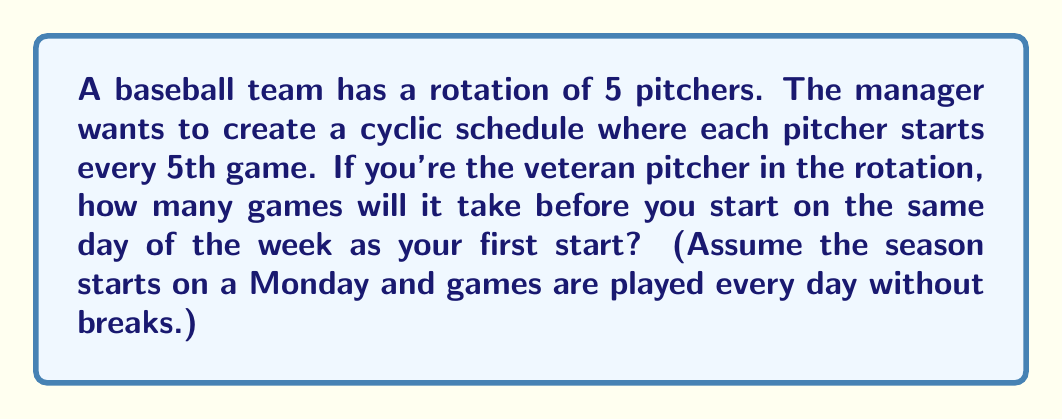Can you answer this question? Let's approach this step-by-step:

1) First, we need to understand what creates the cyclic subgroup in this scenario. The rotation of 5 pitchers combined with the 7 days of the week creates a cyclic pattern.

2) We can represent this as a permutation. Let's call the days of the week $1, 2, 3, 4, 5, 6, 7$ (Monday to Sunday) and our pitcher's position in the rotation as $x$. The permutation can be written as:

   $$(x, x+5, x+10, x+15, ...)$$

   Where we take the result modulo 7 to stay within the days of the week.

3) To find when this cycle repeats, we need to find the least common multiple (LCM) of 5 (the number of pitchers in the rotation) and 7 (the number of days in a week).

4) $LCM(5,7) = 5 \times 7 = 35$ (since 5 and 7 are prime)

5) This means that after 35 games, the cycle will repeat and you'll be pitching on the same day of the week as your first start.

6) To verify:
   - Start: $x$
   - After 5 games: $x+5 \equiv x-2 \pmod{7}$
   - After 10 games: $x+10 \equiv x+3 \pmod{7}$
   - After 15 games: $x+15 \equiv x+1 \pmod{7}$
   - After 20 games: $x+20 \equiv x-1 \pmod{7}$
   - After 25 games: $x+25 \equiv x+4 \pmod{7}$
   - After 30 games: $x+30 \equiv x+2 \pmod{7}$
   - After 35 games: $x+35 \equiv x \pmod{7}$

Therefore, the order of this cyclic subgroup is 35.
Answer: 35 games 